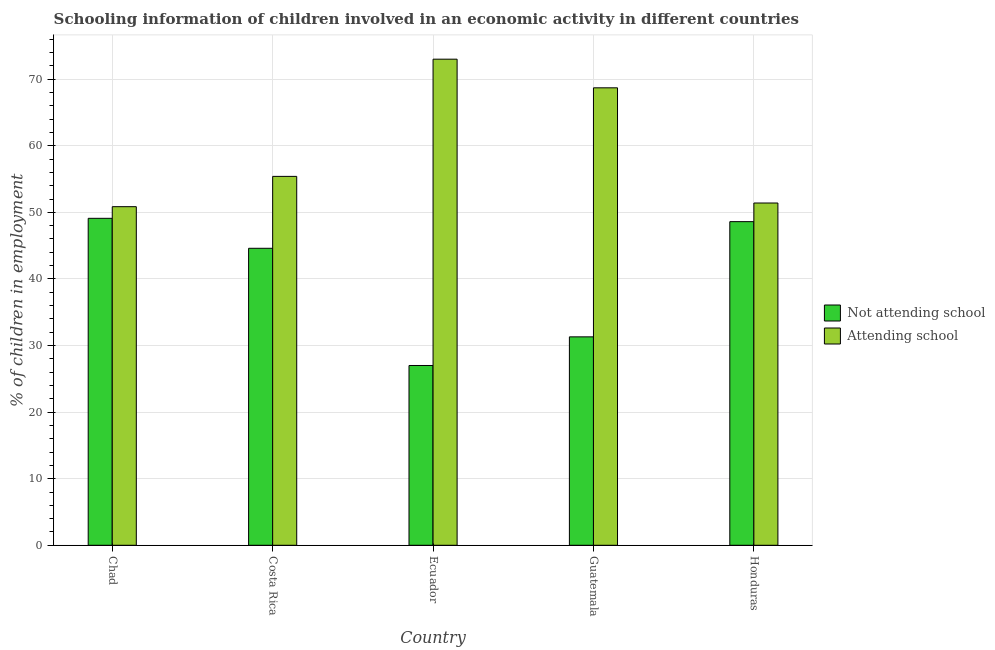Are the number of bars per tick equal to the number of legend labels?
Offer a very short reply. Yes. What is the label of the 4th group of bars from the left?
Provide a short and direct response. Guatemala. What is the percentage of employed children who are not attending school in Costa Rica?
Your answer should be very brief. 44.6. Across all countries, what is the maximum percentage of employed children who are not attending school?
Give a very brief answer. 49.1. In which country was the percentage of employed children who are not attending school maximum?
Offer a very short reply. Chad. In which country was the percentage of employed children who are not attending school minimum?
Your response must be concise. Ecuador. What is the total percentage of employed children who are attending school in the graph?
Offer a very short reply. 299.35. What is the difference between the percentage of employed children who are attending school in Chad and that in Costa Rica?
Keep it short and to the point. -4.55. What is the difference between the percentage of employed children who are attending school in Ecuador and the percentage of employed children who are not attending school in Guatemala?
Give a very brief answer. 41.7. What is the average percentage of employed children who are attending school per country?
Ensure brevity in your answer.  59.87. What is the difference between the percentage of employed children who are not attending school and percentage of employed children who are attending school in Ecuador?
Offer a terse response. -46. What is the ratio of the percentage of employed children who are attending school in Costa Rica to that in Honduras?
Make the answer very short. 1.08. Is the percentage of employed children who are not attending school in Chad less than that in Guatemala?
Ensure brevity in your answer.  No. Is the difference between the percentage of employed children who are not attending school in Costa Rica and Ecuador greater than the difference between the percentage of employed children who are attending school in Costa Rica and Ecuador?
Keep it short and to the point. Yes. What is the difference between the highest and the second highest percentage of employed children who are attending school?
Give a very brief answer. 4.3. What is the difference between the highest and the lowest percentage of employed children who are not attending school?
Keep it short and to the point. 22.1. In how many countries, is the percentage of employed children who are not attending school greater than the average percentage of employed children who are not attending school taken over all countries?
Your answer should be very brief. 3. Is the sum of the percentage of employed children who are attending school in Ecuador and Honduras greater than the maximum percentage of employed children who are not attending school across all countries?
Offer a very short reply. Yes. What does the 1st bar from the left in Guatemala represents?
Offer a very short reply. Not attending school. What does the 1st bar from the right in Ecuador represents?
Give a very brief answer. Attending school. How many bars are there?
Ensure brevity in your answer.  10. Does the graph contain grids?
Your answer should be compact. Yes. How many legend labels are there?
Offer a very short reply. 2. What is the title of the graph?
Offer a very short reply. Schooling information of children involved in an economic activity in different countries. Does "Domestic Liabilities" appear as one of the legend labels in the graph?
Provide a short and direct response. No. What is the label or title of the Y-axis?
Keep it short and to the point. % of children in employment. What is the % of children in employment in Not attending school in Chad?
Provide a short and direct response. 49.1. What is the % of children in employment of Attending school in Chad?
Make the answer very short. 50.85. What is the % of children in employment of Not attending school in Costa Rica?
Ensure brevity in your answer.  44.6. What is the % of children in employment in Attending school in Costa Rica?
Provide a succinct answer. 55.4. What is the % of children in employment in Not attending school in Guatemala?
Your answer should be very brief. 31.3. What is the % of children in employment in Attending school in Guatemala?
Give a very brief answer. 68.7. What is the % of children in employment in Not attending school in Honduras?
Give a very brief answer. 48.6. What is the % of children in employment of Attending school in Honduras?
Provide a short and direct response. 51.4. Across all countries, what is the maximum % of children in employment of Not attending school?
Offer a very short reply. 49.1. Across all countries, what is the minimum % of children in employment in Attending school?
Provide a succinct answer. 50.85. What is the total % of children in employment in Not attending school in the graph?
Your answer should be very brief. 200.6. What is the total % of children in employment of Attending school in the graph?
Give a very brief answer. 299.35. What is the difference between the % of children in employment in Not attending school in Chad and that in Costa Rica?
Keep it short and to the point. 4.5. What is the difference between the % of children in employment in Attending school in Chad and that in Costa Rica?
Your response must be concise. -4.55. What is the difference between the % of children in employment of Not attending school in Chad and that in Ecuador?
Provide a succinct answer. 22.1. What is the difference between the % of children in employment in Attending school in Chad and that in Ecuador?
Provide a short and direct response. -22.15. What is the difference between the % of children in employment in Not attending school in Chad and that in Guatemala?
Your answer should be very brief. 17.8. What is the difference between the % of children in employment in Attending school in Chad and that in Guatemala?
Your response must be concise. -17.85. What is the difference between the % of children in employment of Not attending school in Chad and that in Honduras?
Make the answer very short. 0.5. What is the difference between the % of children in employment of Attending school in Chad and that in Honduras?
Make the answer very short. -0.55. What is the difference between the % of children in employment of Not attending school in Costa Rica and that in Ecuador?
Your answer should be very brief. 17.6. What is the difference between the % of children in employment of Attending school in Costa Rica and that in Ecuador?
Provide a short and direct response. -17.6. What is the difference between the % of children in employment of Not attending school in Costa Rica and that in Honduras?
Offer a terse response. -4. What is the difference between the % of children in employment of Not attending school in Ecuador and that in Honduras?
Ensure brevity in your answer.  -21.6. What is the difference between the % of children in employment of Attending school in Ecuador and that in Honduras?
Provide a short and direct response. 21.6. What is the difference between the % of children in employment in Not attending school in Guatemala and that in Honduras?
Provide a succinct answer. -17.3. What is the difference between the % of children in employment of Not attending school in Chad and the % of children in employment of Attending school in Ecuador?
Provide a short and direct response. -23.9. What is the difference between the % of children in employment in Not attending school in Chad and the % of children in employment in Attending school in Guatemala?
Your answer should be compact. -19.6. What is the difference between the % of children in employment in Not attending school in Chad and the % of children in employment in Attending school in Honduras?
Offer a terse response. -2.3. What is the difference between the % of children in employment of Not attending school in Costa Rica and the % of children in employment of Attending school in Ecuador?
Your answer should be very brief. -28.4. What is the difference between the % of children in employment of Not attending school in Costa Rica and the % of children in employment of Attending school in Guatemala?
Your answer should be compact. -24.1. What is the difference between the % of children in employment of Not attending school in Costa Rica and the % of children in employment of Attending school in Honduras?
Offer a very short reply. -6.8. What is the difference between the % of children in employment in Not attending school in Ecuador and the % of children in employment in Attending school in Guatemala?
Your answer should be compact. -41.7. What is the difference between the % of children in employment in Not attending school in Ecuador and the % of children in employment in Attending school in Honduras?
Offer a very short reply. -24.4. What is the difference between the % of children in employment in Not attending school in Guatemala and the % of children in employment in Attending school in Honduras?
Your answer should be compact. -20.1. What is the average % of children in employment in Not attending school per country?
Give a very brief answer. 40.12. What is the average % of children in employment of Attending school per country?
Provide a short and direct response. 59.87. What is the difference between the % of children in employment of Not attending school and % of children in employment of Attending school in Chad?
Your answer should be very brief. -1.75. What is the difference between the % of children in employment of Not attending school and % of children in employment of Attending school in Costa Rica?
Ensure brevity in your answer.  -10.8. What is the difference between the % of children in employment of Not attending school and % of children in employment of Attending school in Ecuador?
Keep it short and to the point. -46. What is the difference between the % of children in employment in Not attending school and % of children in employment in Attending school in Guatemala?
Ensure brevity in your answer.  -37.4. What is the ratio of the % of children in employment of Not attending school in Chad to that in Costa Rica?
Ensure brevity in your answer.  1.1. What is the ratio of the % of children in employment of Attending school in Chad to that in Costa Rica?
Your answer should be compact. 0.92. What is the ratio of the % of children in employment in Not attending school in Chad to that in Ecuador?
Offer a terse response. 1.82. What is the ratio of the % of children in employment of Attending school in Chad to that in Ecuador?
Ensure brevity in your answer.  0.7. What is the ratio of the % of children in employment in Not attending school in Chad to that in Guatemala?
Keep it short and to the point. 1.57. What is the ratio of the % of children in employment of Attending school in Chad to that in Guatemala?
Your answer should be very brief. 0.74. What is the ratio of the % of children in employment of Not attending school in Chad to that in Honduras?
Your answer should be compact. 1.01. What is the ratio of the % of children in employment in Attending school in Chad to that in Honduras?
Your answer should be very brief. 0.99. What is the ratio of the % of children in employment of Not attending school in Costa Rica to that in Ecuador?
Offer a very short reply. 1.65. What is the ratio of the % of children in employment in Attending school in Costa Rica to that in Ecuador?
Provide a succinct answer. 0.76. What is the ratio of the % of children in employment of Not attending school in Costa Rica to that in Guatemala?
Your answer should be compact. 1.42. What is the ratio of the % of children in employment of Attending school in Costa Rica to that in Guatemala?
Offer a terse response. 0.81. What is the ratio of the % of children in employment in Not attending school in Costa Rica to that in Honduras?
Your answer should be very brief. 0.92. What is the ratio of the % of children in employment in Attending school in Costa Rica to that in Honduras?
Your answer should be compact. 1.08. What is the ratio of the % of children in employment of Not attending school in Ecuador to that in Guatemala?
Your response must be concise. 0.86. What is the ratio of the % of children in employment of Attending school in Ecuador to that in Guatemala?
Provide a succinct answer. 1.06. What is the ratio of the % of children in employment of Not attending school in Ecuador to that in Honduras?
Ensure brevity in your answer.  0.56. What is the ratio of the % of children in employment of Attending school in Ecuador to that in Honduras?
Ensure brevity in your answer.  1.42. What is the ratio of the % of children in employment of Not attending school in Guatemala to that in Honduras?
Provide a succinct answer. 0.64. What is the ratio of the % of children in employment in Attending school in Guatemala to that in Honduras?
Make the answer very short. 1.34. What is the difference between the highest and the second highest % of children in employment of Not attending school?
Offer a very short reply. 0.5. What is the difference between the highest and the lowest % of children in employment of Not attending school?
Give a very brief answer. 22.1. What is the difference between the highest and the lowest % of children in employment of Attending school?
Provide a short and direct response. 22.15. 